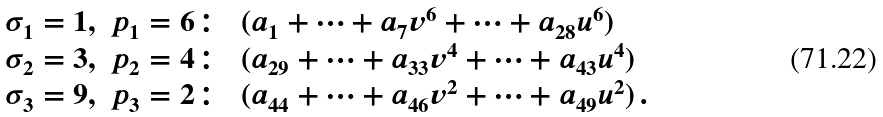Convert formula to latex. <formula><loc_0><loc_0><loc_500><loc_500>\begin{array} { l l l } \sigma _ { 1 } = 1 , & p _ { 1 } = 6 \colon & ( a _ { 1 } + \dots + a _ { 7 } v ^ { 6 } + \dots + a _ { 2 8 } u ^ { 6 } ) \\ \sigma _ { 2 } = 3 , & p _ { 2 } = 4 \colon & ( a _ { 2 9 } + \dots + a _ { 3 3 } v ^ { 4 } + \dots + a _ { 4 3 } u ^ { 4 } ) \\ \sigma _ { 3 } = 9 , & p _ { 3 } = 2 \colon & ( a _ { 4 4 } + \dots + a _ { 4 6 } v ^ { 2 } + \dots + a _ { 4 9 } u ^ { 2 } ) \, . \end{array}</formula> 